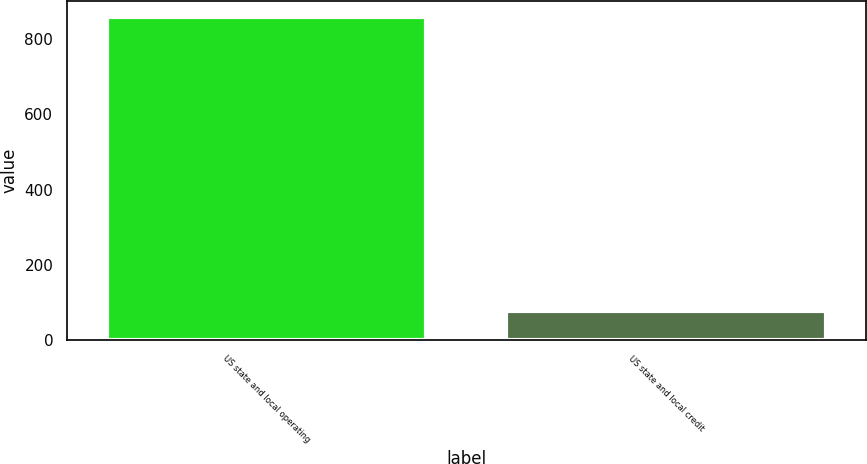Convert chart to OTSL. <chart><loc_0><loc_0><loc_500><loc_500><bar_chart><fcel>US state and local operating<fcel>US state and local credit<nl><fcel>859<fcel>77<nl></chart> 